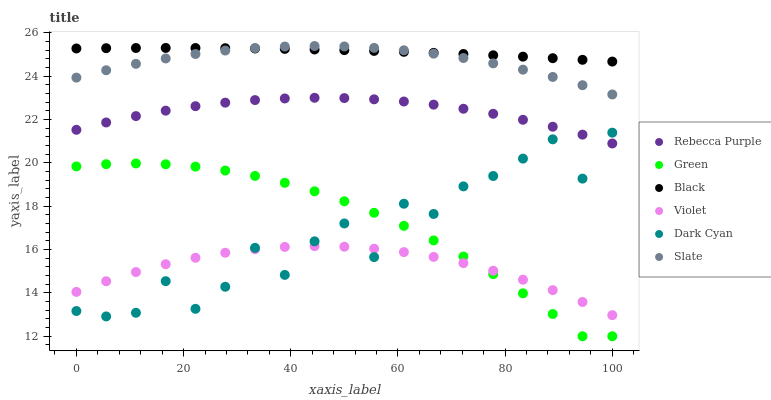Does Violet have the minimum area under the curve?
Answer yes or no. Yes. Does Black have the maximum area under the curve?
Answer yes or no. Yes. Does Rebecca Purple have the minimum area under the curve?
Answer yes or no. No. Does Rebecca Purple have the maximum area under the curve?
Answer yes or no. No. Is Black the smoothest?
Answer yes or no. Yes. Is Dark Cyan the roughest?
Answer yes or no. Yes. Is Rebecca Purple the smoothest?
Answer yes or no. No. Is Rebecca Purple the roughest?
Answer yes or no. No. Does Green have the lowest value?
Answer yes or no. Yes. Does Rebecca Purple have the lowest value?
Answer yes or no. No. Does Slate have the highest value?
Answer yes or no. Yes. Does Black have the highest value?
Answer yes or no. No. Is Green less than Black?
Answer yes or no. Yes. Is Black greater than Dark Cyan?
Answer yes or no. Yes. Does Green intersect Violet?
Answer yes or no. Yes. Is Green less than Violet?
Answer yes or no. No. Is Green greater than Violet?
Answer yes or no. No. Does Green intersect Black?
Answer yes or no. No. 